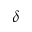Convert formula to latex. <formula><loc_0><loc_0><loc_500><loc_500>\delta</formula> 